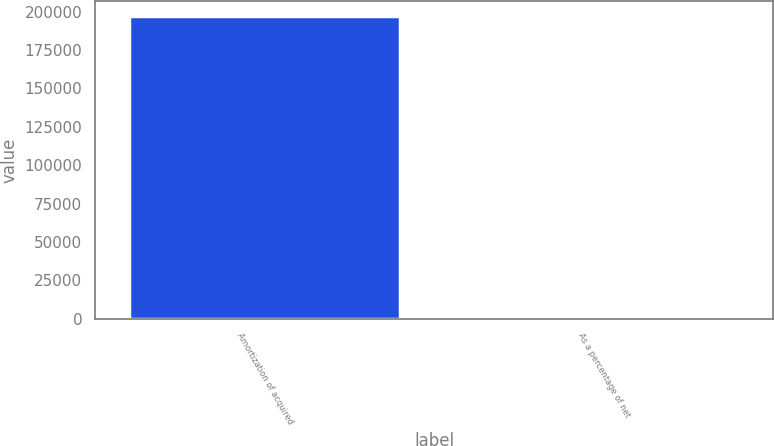<chart> <loc_0><loc_0><loc_500><loc_500><bar_chart><fcel>Amortization of acquired<fcel>As a percentage of net<nl><fcel>197078<fcel>3.3<nl></chart> 